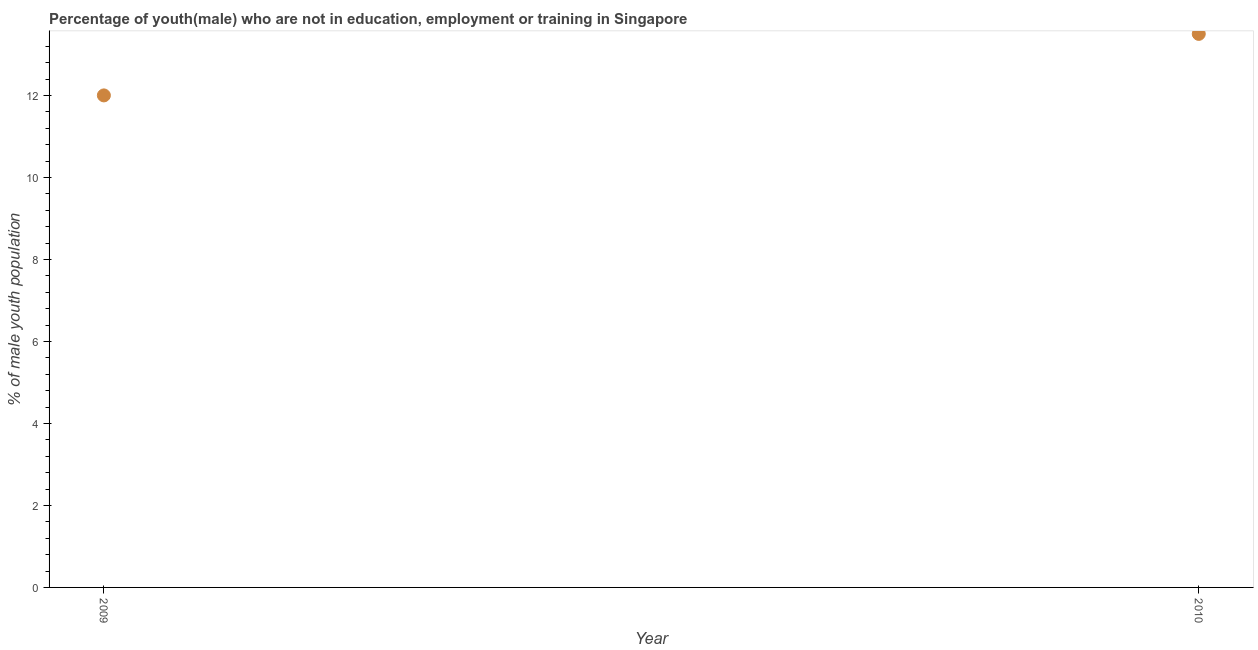What is the unemployed male youth population in 2009?
Offer a terse response. 12. Across all years, what is the maximum unemployed male youth population?
Offer a very short reply. 13.5. In which year was the unemployed male youth population maximum?
Offer a very short reply. 2010. What is the difference between the unemployed male youth population in 2009 and 2010?
Your answer should be very brief. -1.5. What is the average unemployed male youth population per year?
Your answer should be compact. 12.75. What is the median unemployed male youth population?
Give a very brief answer. 12.75. Do a majority of the years between 2009 and 2010 (inclusive) have unemployed male youth population greater than 7.6 %?
Offer a very short reply. Yes. What is the ratio of the unemployed male youth population in 2009 to that in 2010?
Offer a terse response. 0.89. In how many years, is the unemployed male youth population greater than the average unemployed male youth population taken over all years?
Provide a short and direct response. 1. Does the unemployed male youth population monotonically increase over the years?
Ensure brevity in your answer.  Yes. How many dotlines are there?
Ensure brevity in your answer.  1. Does the graph contain any zero values?
Offer a terse response. No. What is the title of the graph?
Ensure brevity in your answer.  Percentage of youth(male) who are not in education, employment or training in Singapore. What is the label or title of the Y-axis?
Keep it short and to the point. % of male youth population. What is the % of male youth population in 2009?
Your response must be concise. 12. What is the difference between the % of male youth population in 2009 and 2010?
Keep it short and to the point. -1.5. What is the ratio of the % of male youth population in 2009 to that in 2010?
Ensure brevity in your answer.  0.89. 